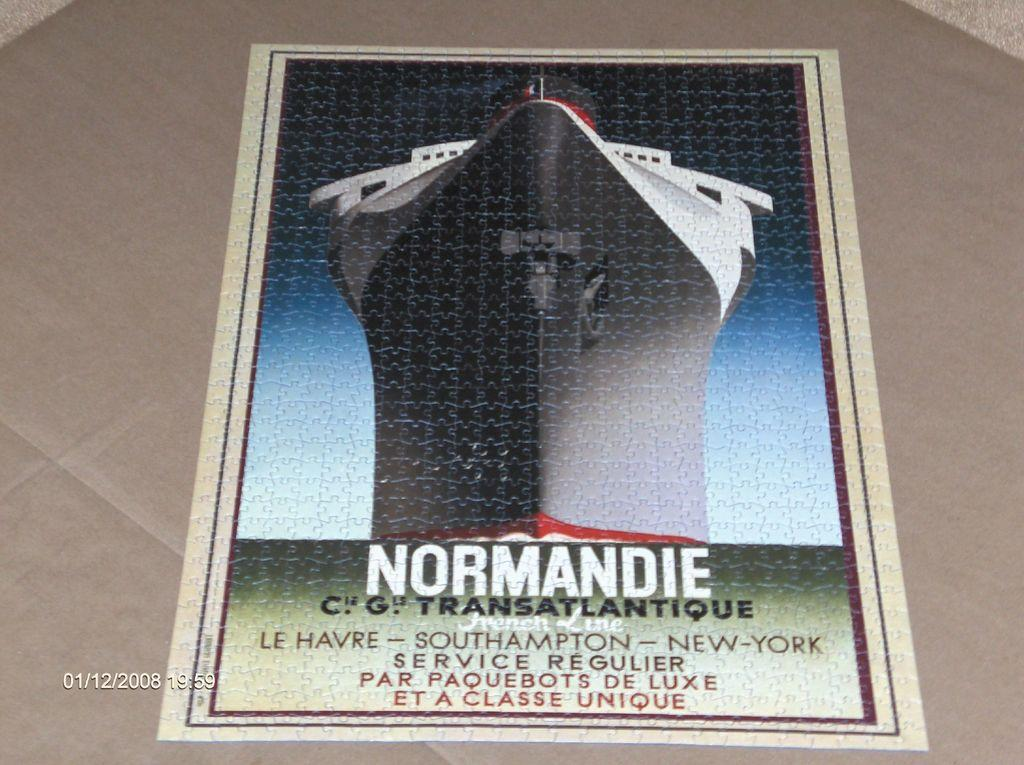Provide a one-sentence caption for the provided image. A puzzle that is put together and reads Normandie in large white letters. 